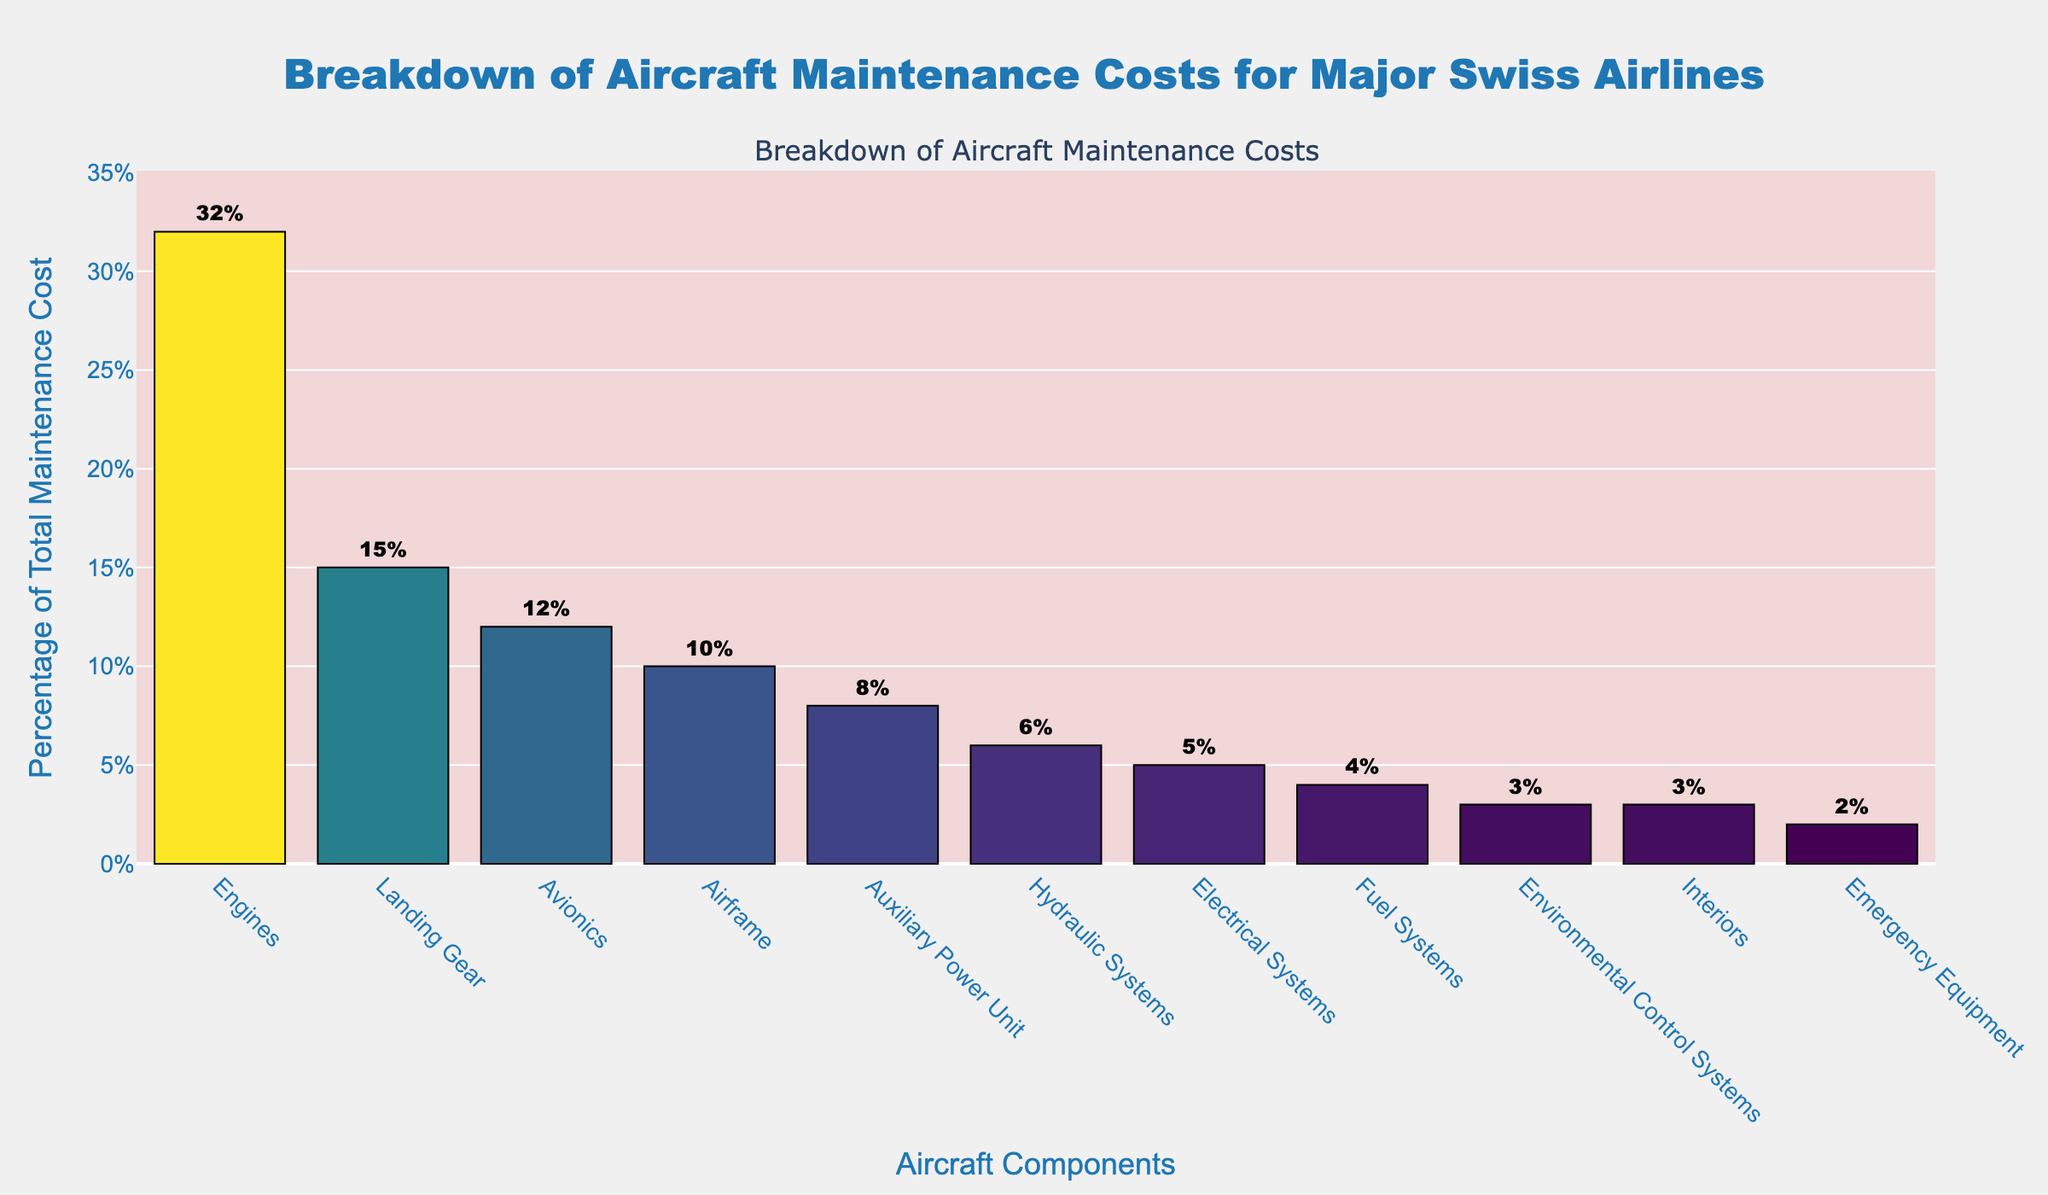Which component has the highest maintenance cost percentage? The bar representing the highest maintenance cost percentage is the "Engines" component.
Answer: Engines What is the combined maintenance cost percentage of the Landing Gear and Avionics components? The maintenance cost percentages for Landing Gear and Avionics are 15% and 12% respectively. Adding them gives 15% + 12% = 27%.
Answer: 27% How does the maintenance cost percentage of Electrical Systems compare to that of Hydraulic Systems? The bar for Electrical Systems shows 5%, while the bar for Hydraulic Systems shows 6%. Therefore, Hydraulic Systems have a higher maintenance cost percentage than Electrical Systems.
Answer: Hydraulic Systems have a higher percentage Which components contribute the least to the maintenance cost, and what is their combined percentage? The components with the smallest percentages are Emergency Equipment and Interiors, each at 2% and 3% respectively. Adding them gives 2% + 3% = 5%.
Answer: Emergency Equipment and Interiors, 5% What is the difference in maintenance cost percentage between Engines and Airframe components? The percentage for Engines is 32%, and for Airframe it is 10%. The difference is 32% - 10% = 22%.
Answer: 22% Which component is closest in maintenance cost percentage to the Auxiliary Power Unit? The Auxiliary Power Unit shows a maintenance cost percentage of 8%. The closest is Hydraulic Systems, which is 6%.
Answer: Hydraulic Systems How does the combined maintenance cost percentage of Fuel Systems and Environmental Control Systems compare to that of Airframe? The percentage for Fuel Systems is 4% and for Environmental Control Systems is 3%, adding them gives 7%. The percentage for Airframe alone is 10%. Therefore, 7% is less than 10%.
Answer: Less than Airframe Identify all components that have over 10% of the total maintenance cost. The bars that exceed 10% are Engines (32%), Landing Gear (15%), and Avionics (12%).
Answer: Engines, Landing Gear, Avionics Which component is represented by the shortest bar and what percentage does it show? The shortest bar represents Emergency Equipment at 2%.
Answer: Emergency Equipment, 2% Arrange the top three maintenance costs in descending order and specify their corresponding components. The top three maintenance costs are 32% for Engines, 15% for Landing Gear, and 12% for Avionics.
Answer: Engines (32%), Landing Gear (15%), Avionics (12%) 